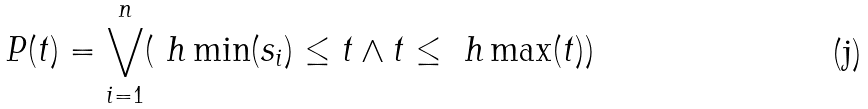Convert formula to latex. <formula><loc_0><loc_0><loc_500><loc_500>P ( t ) = \bigvee _ { i = 1 } ^ { n } ( \ h \min ( s _ { i } ) \leq t \land t \leq \ h \max ( t ) )</formula> 